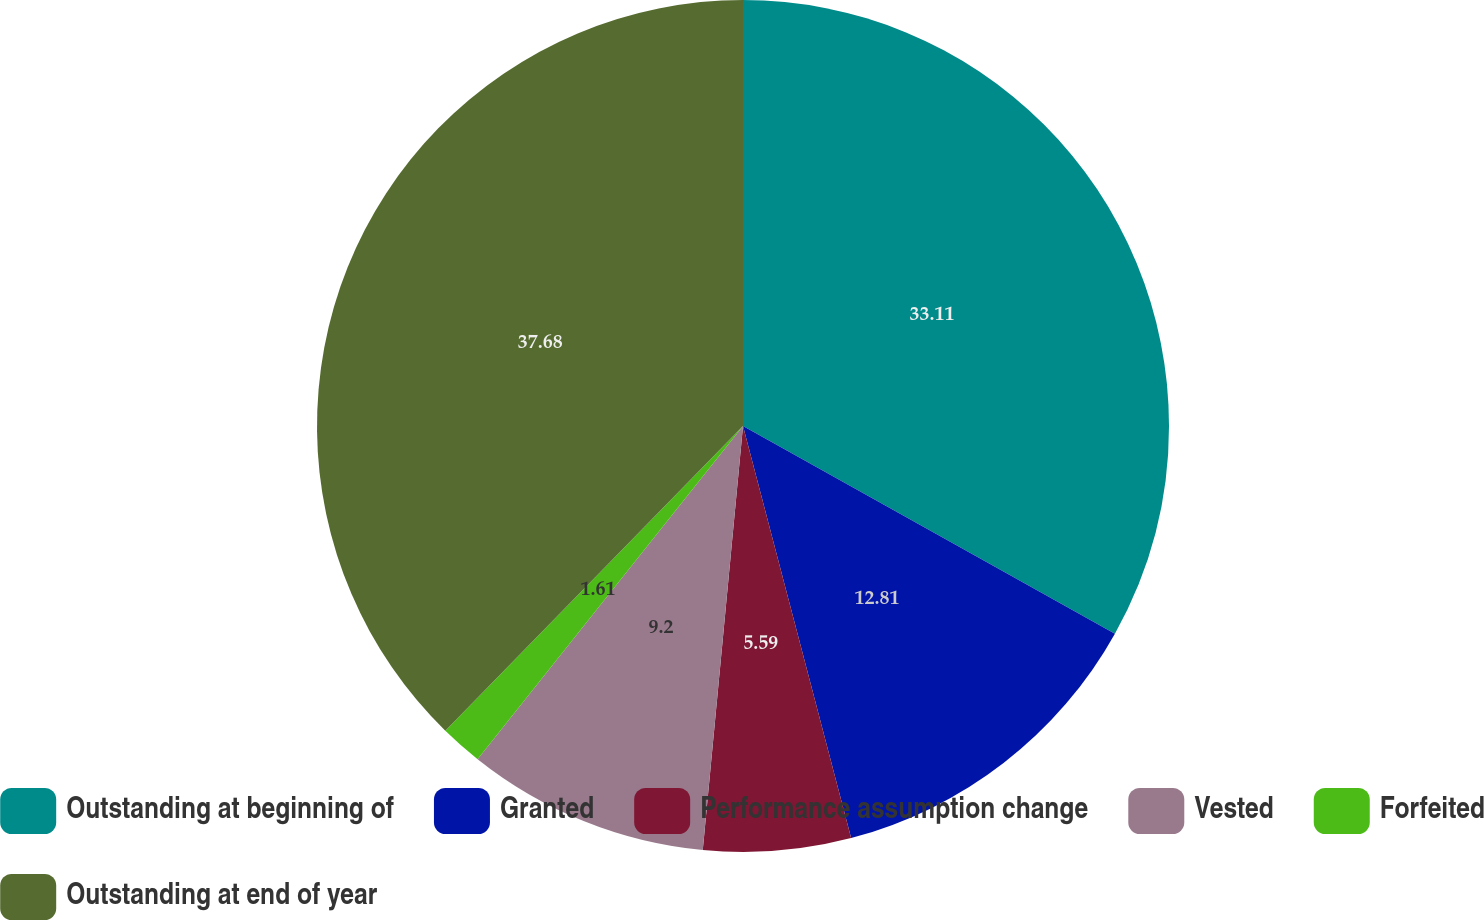Convert chart to OTSL. <chart><loc_0><loc_0><loc_500><loc_500><pie_chart><fcel>Outstanding at beginning of<fcel>Granted<fcel>Performance assumption change<fcel>Vested<fcel>Forfeited<fcel>Outstanding at end of year<nl><fcel>33.11%<fcel>12.81%<fcel>5.59%<fcel>9.2%<fcel>1.61%<fcel>37.69%<nl></chart> 